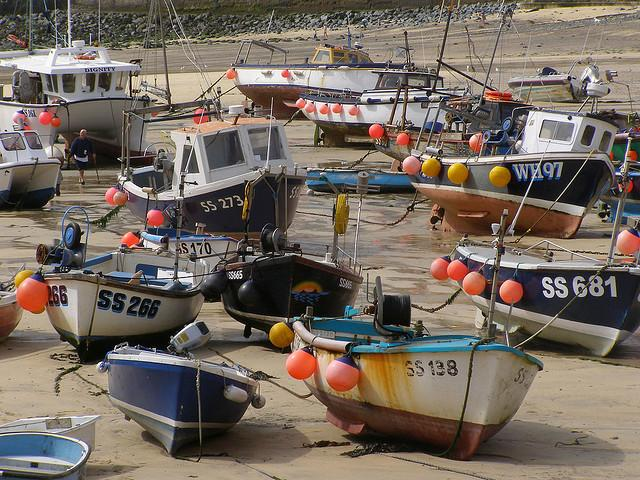What boat number is the largest here? Please explain your reasoning. 681. This is the largest of all the numbers on the boats. 